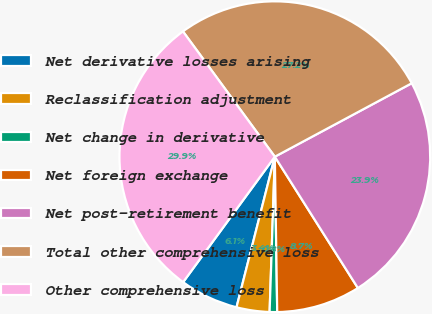<chart> <loc_0><loc_0><loc_500><loc_500><pie_chart><fcel>Net derivative losses arising<fcel>Reclassification adjustment<fcel>Net change in derivative<fcel>Net foreign exchange<fcel>Net post-retirement benefit<fcel>Total other comprehensive loss<fcel>Other comprehensive loss<nl><fcel>6.08%<fcel>3.43%<fcel>0.78%<fcel>8.73%<fcel>23.86%<fcel>27.23%<fcel>29.88%<nl></chart> 